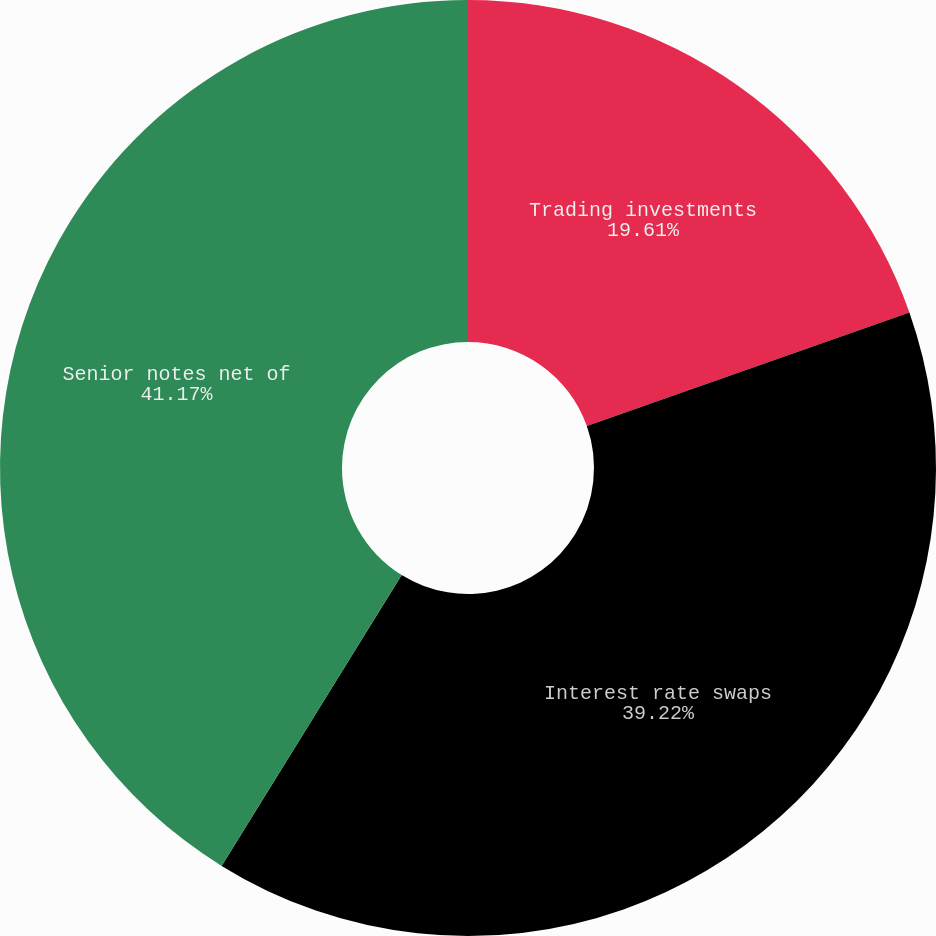Convert chart to OTSL. <chart><loc_0><loc_0><loc_500><loc_500><pie_chart><fcel>Trading investments<fcel>Interest rate swaps<fcel>Senior notes net of<nl><fcel>19.61%<fcel>39.22%<fcel>41.18%<nl></chart> 